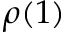<formula> <loc_0><loc_0><loc_500><loc_500>\rho ( 1 )</formula> 